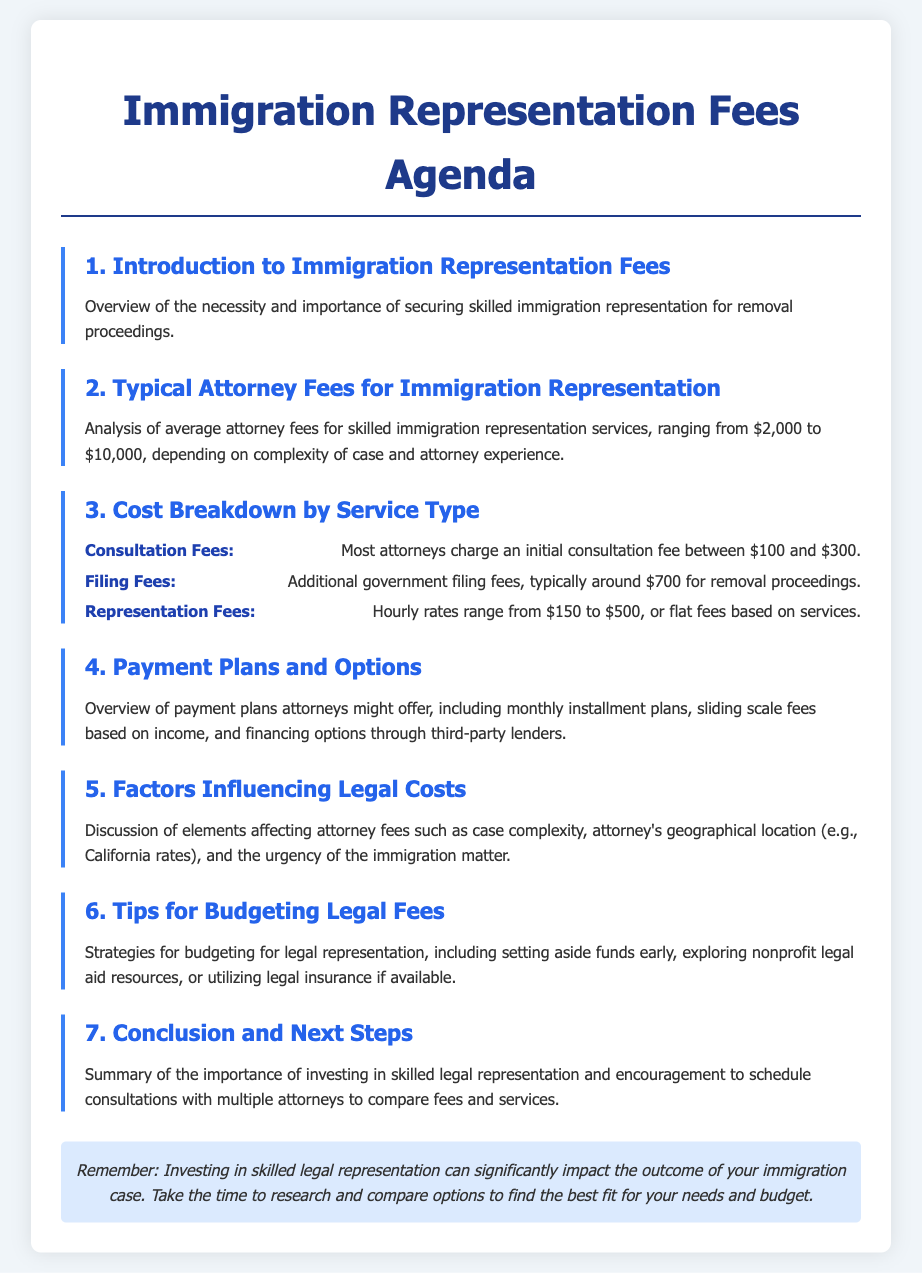What is the range of typical attorney fees for immigration representation? The range of typical attorney fees for immigration representation is between $2,000 and $10,000.
Answer: $2,000 to $10,000 What is the typical initial consultation fee charged by most attorneys? Most attorneys charge an initial consultation fee between $100 and $300.
Answer: $100 to $300 What is the average government filing fee for removal proceedings? The additional government filing fee for removal proceedings is typically around $700.
Answer: $700 What factors can influence legal costs? Elements affecting attorney fees can include case complexity, attorney's geographical location, and urgency of the immigration matter.
Answer: Case complexity, location, urgency What does the document recommend for budgeting legal fees? The document suggests budgeting strategies like setting aside funds early and exploring nonprofit legal aid resources.
Answer: Setting aside funds early Which payment plans might attorneys offer? Attorneys might offer monthly installment plans, sliding scale fees, and financing options through third-party lenders.
Answer: Monthly installment plans, sliding scale fees, financing options What is the main conclusion of the document? The main conclusion emphasizes the importance of investing in skilled legal representation and comparing options.
Answer: Importance of investing in skilled legal representation What does the agenda emphasize after discussing attorney fees? The agenda emphasizes scheduling consultations with multiple attorneys to compare fees and services.
Answer: Scheduling consultations with multiple attorneys 